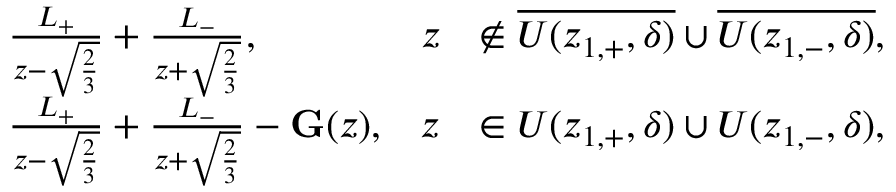<formula> <loc_0><loc_0><loc_500><loc_500>\begin{array} { r l r l } & { \frac { L _ { + } } { z - \sqrt { \frac { 2 } { 3 } } } + \frac { L _ { - } } { z + \sqrt { \frac { 2 } { 3 } } } , } & { z } & { \notin \overline { { U ( z _ { 1 , + } , \delta ) } } \cup \overline { { U ( z _ { 1 , - } , \delta ) } } , } \\ & { \frac { L _ { + } } { z - \sqrt { \frac { 2 } { 3 } } } + \frac { L _ { - } } { z + \sqrt { \frac { 2 } { 3 } } } - G ( z ) , } & { z } & { \in U ( z _ { 1 , + } , \delta ) \cup U ( z _ { 1 , - } , \delta ) , } \end{array}</formula> 